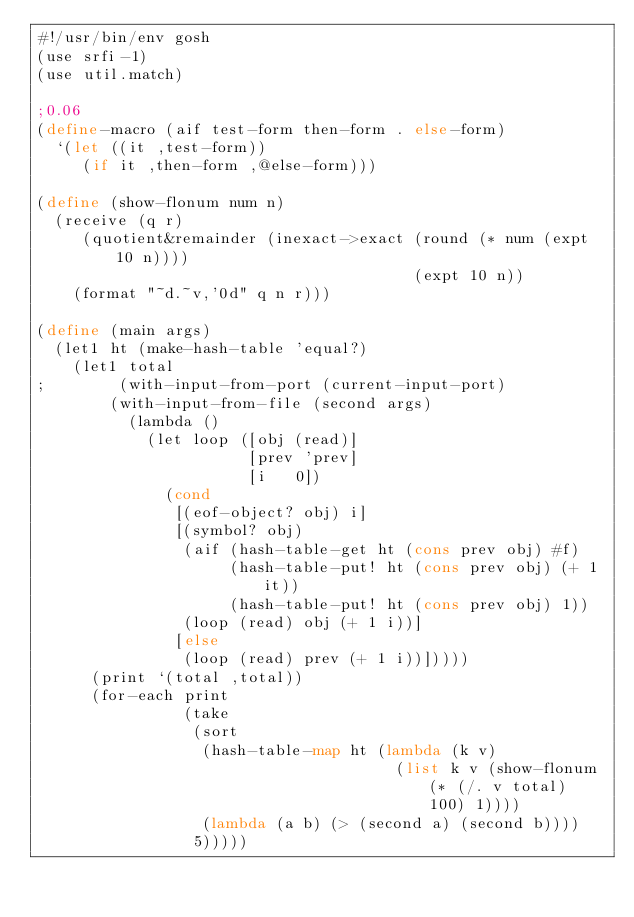Convert code to text. <code><loc_0><loc_0><loc_500><loc_500><_Scheme_>#!/usr/bin/env gosh
(use srfi-1)
(use util.match)

;0.06
(define-macro (aif test-form then-form . else-form)
  `(let ((it ,test-form))
     (if it ,then-form ,@else-form)))

(define (show-flonum num n)
  (receive (q r)
     (quotient&remainder (inexact->exact (round (* num (expt 10 n))))
                                         (expt 10 n))
    (format "~d.~v,'0d" q n r)))

(define (main args)
  (let1 ht (make-hash-table 'equal?)
    (let1 total
;        (with-input-from-port (current-input-port)
        (with-input-from-file (second args)
          (lambda ()
            (let loop ([obj (read)]
                       [prev 'prev]
                       [i   0])
              (cond
               [(eof-object? obj) i]
               [(symbol? obj)
                (aif (hash-table-get ht (cons prev obj) #f)
                     (hash-table-put! ht (cons prev obj) (+ 1 it))
                     (hash-table-put! ht (cons prev obj) 1))
                (loop (read) obj (+ 1 i))]
               [else
                (loop (read) prev (+ 1 i))]))))
      (print `(total ,total))
      (for-each print
                (take
                 (sort
                  (hash-table-map ht (lambda (k v)
                                       (list k v (show-flonum (* (/. v total) 100) 1))))
                  (lambda (a b) (> (second a) (second b))))
                 5)))))
</code> 